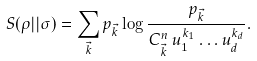<formula> <loc_0><loc_0><loc_500><loc_500>S ( \rho | | \sigma ) = \sum _ { \vec { k } } p _ { \vec { k } } \log \frac { p _ { \vec { k } } } { C ^ { n } _ { \vec { k } } \, u _ { 1 } ^ { k _ { 1 } } \dots u _ { d } ^ { k _ { d } } } .</formula> 